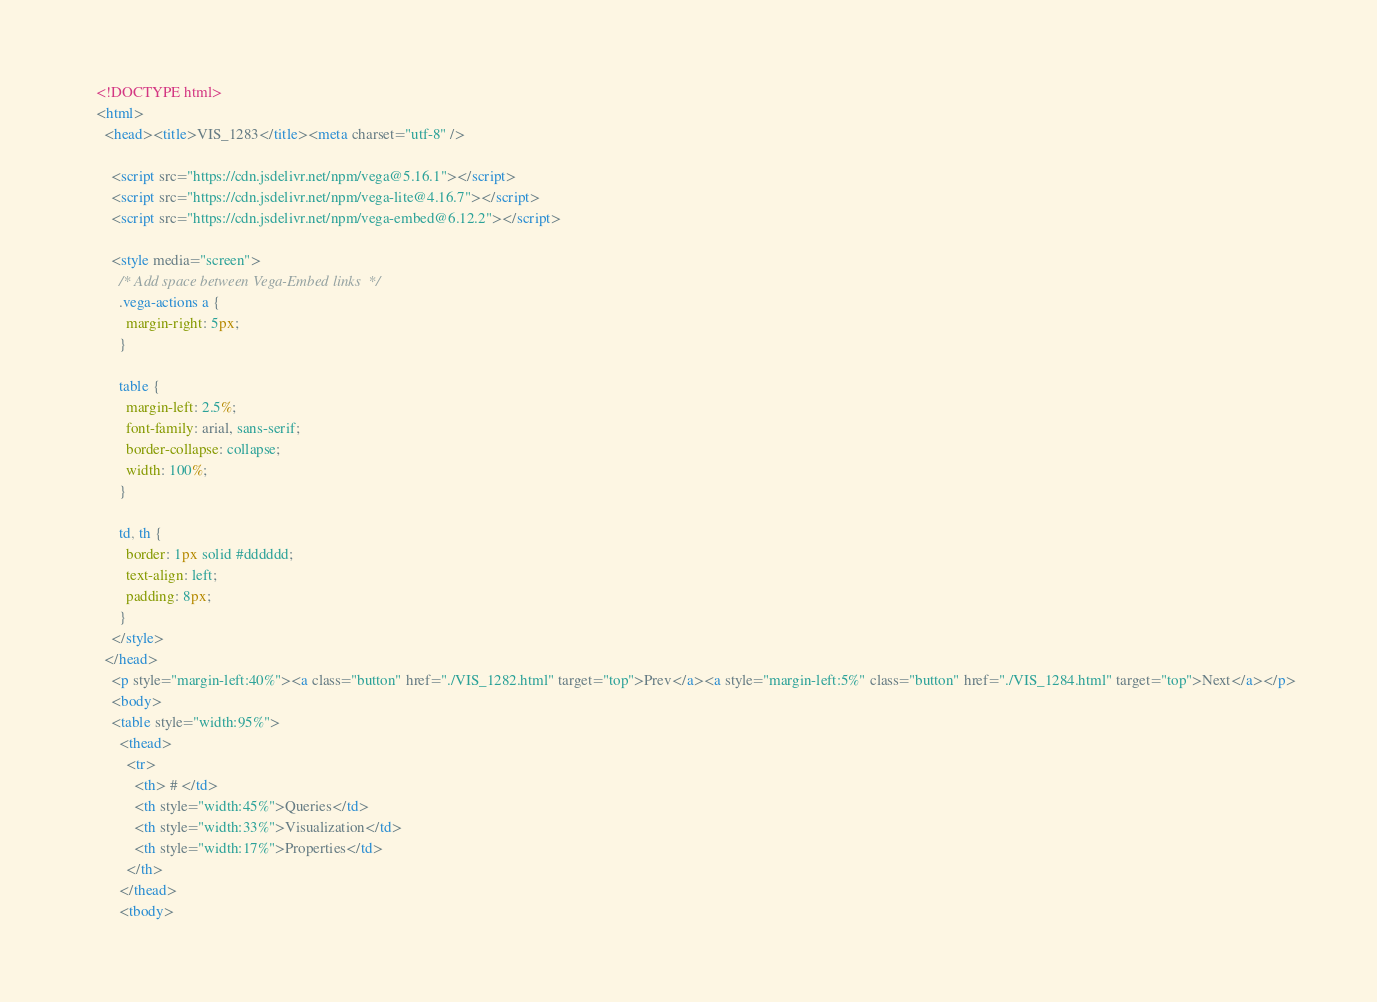Convert code to text. <code><loc_0><loc_0><loc_500><loc_500><_HTML_>
    <!DOCTYPE html>
    <html>
      <head><title>VIS_1283</title><meta charset="utf-8" />

        <script src="https://cdn.jsdelivr.net/npm/vega@5.16.1"></script>
        <script src="https://cdn.jsdelivr.net/npm/vega-lite@4.16.7"></script>
        <script src="https://cdn.jsdelivr.net/npm/vega-embed@6.12.2"></script>

        <style media="screen">
          /* Add space between Vega-Embed links  */
          .vega-actions a {
            margin-right: 5px;
          }

          table {
            margin-left: 2.5%;
            font-family: arial, sans-serif;
            border-collapse: collapse;
            width: 100%;
          }

          td, th {
            border: 1px solid #dddddd;
            text-align: left;
            padding: 8px;
          }
        </style>
      </head>
        <p style="margin-left:40%"><a class="button" href="./VIS_1282.html" target="top">Prev</a><a style="margin-left:5%" class="button" href="./VIS_1284.html" target="top">Next</a></p>
        <body>
        <table style="width:95%">
          <thead>
            <tr>
              <th> # </td>
              <th style="width:45%">Queries</td>
              <th style="width:33%">Visualization</td>
              <th style="width:17%">Properties</td>
            </th>
          </thead>
          <tbody></code> 